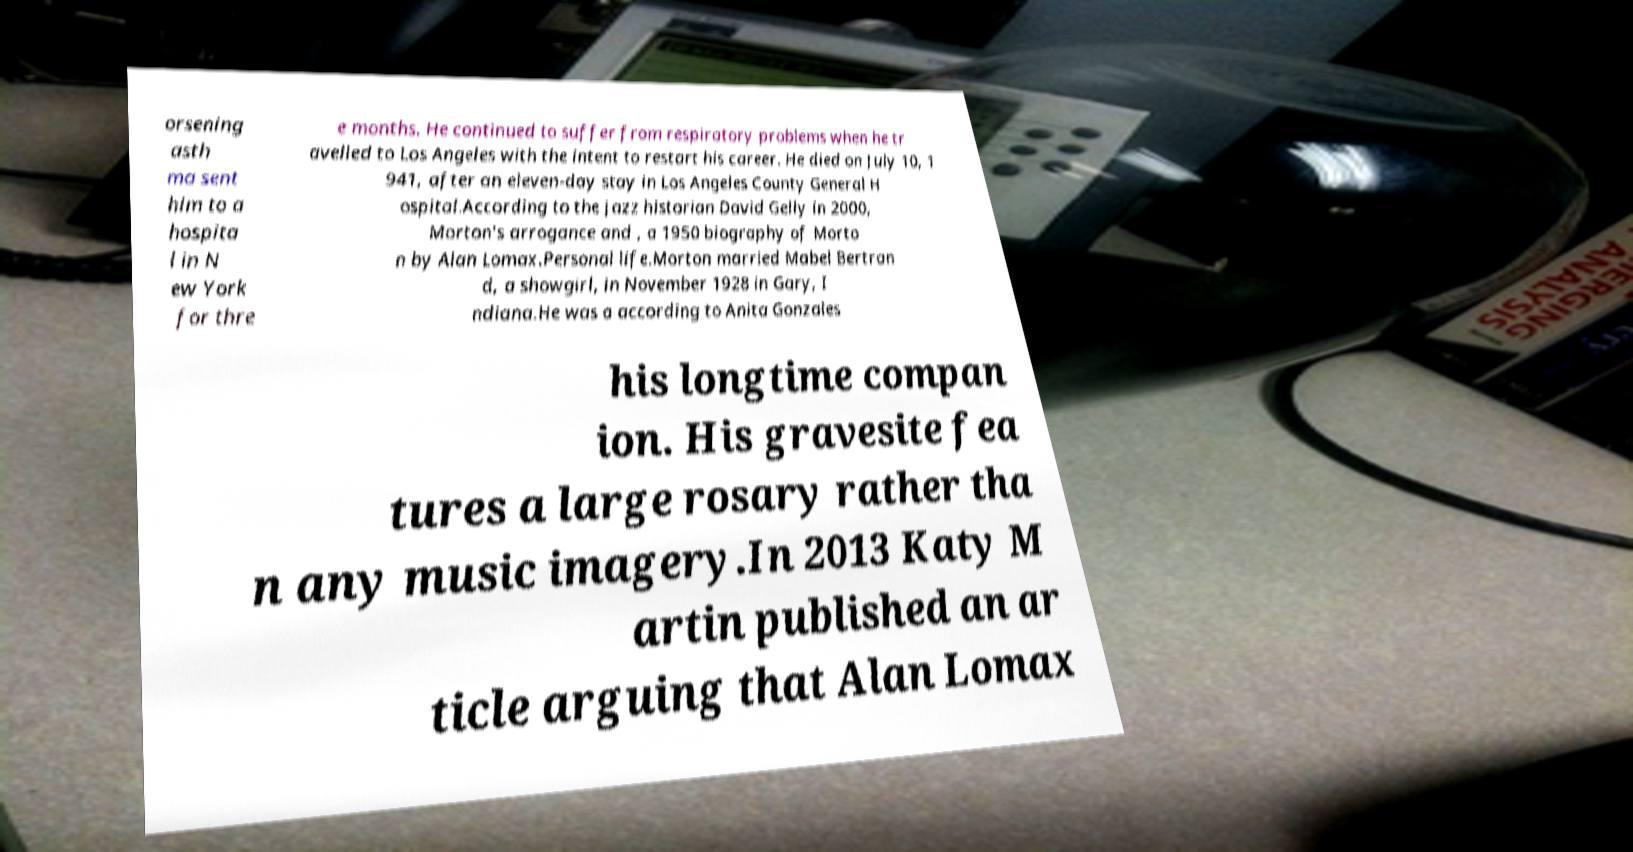I need the written content from this picture converted into text. Can you do that? orsening asth ma sent him to a hospita l in N ew York for thre e months. He continued to suffer from respiratory problems when he tr avelled to Los Angeles with the intent to restart his career. He died on July 10, 1 941, after an eleven-day stay in Los Angeles County General H ospital.According to the jazz historian David Gelly in 2000, Morton's arrogance and , a 1950 biography of Morto n by Alan Lomax.Personal life.Morton married Mabel Bertran d, a showgirl, in November 1928 in Gary, I ndiana.He was a according to Anita Gonzales his longtime compan ion. His gravesite fea tures a large rosary rather tha n any music imagery.In 2013 Katy M artin published an ar ticle arguing that Alan Lomax 